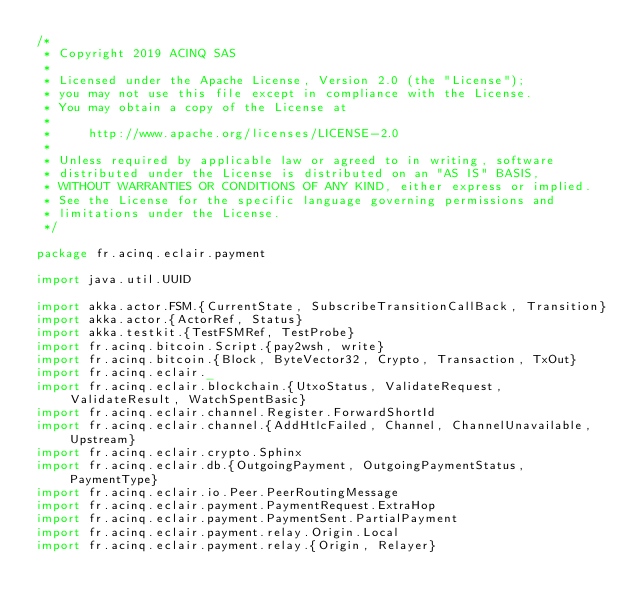Convert code to text. <code><loc_0><loc_0><loc_500><loc_500><_Scala_>/*
 * Copyright 2019 ACINQ SAS
 *
 * Licensed under the Apache License, Version 2.0 (the "License");
 * you may not use this file except in compliance with the License.
 * You may obtain a copy of the License at
 *
 *     http://www.apache.org/licenses/LICENSE-2.0
 *
 * Unless required by applicable law or agreed to in writing, software
 * distributed under the License is distributed on an "AS IS" BASIS,
 * WITHOUT WARRANTIES OR CONDITIONS OF ANY KIND, either express or implied.
 * See the License for the specific language governing permissions and
 * limitations under the License.
 */

package fr.acinq.eclair.payment

import java.util.UUID

import akka.actor.FSM.{CurrentState, SubscribeTransitionCallBack, Transition}
import akka.actor.{ActorRef, Status}
import akka.testkit.{TestFSMRef, TestProbe}
import fr.acinq.bitcoin.Script.{pay2wsh, write}
import fr.acinq.bitcoin.{Block, ByteVector32, Crypto, Transaction, TxOut}
import fr.acinq.eclair._
import fr.acinq.eclair.blockchain.{UtxoStatus, ValidateRequest, ValidateResult, WatchSpentBasic}
import fr.acinq.eclair.channel.Register.ForwardShortId
import fr.acinq.eclair.channel.{AddHtlcFailed, Channel, ChannelUnavailable, Upstream}
import fr.acinq.eclair.crypto.Sphinx
import fr.acinq.eclair.db.{OutgoingPayment, OutgoingPaymentStatus, PaymentType}
import fr.acinq.eclair.io.Peer.PeerRoutingMessage
import fr.acinq.eclair.payment.PaymentRequest.ExtraHop
import fr.acinq.eclair.payment.PaymentSent.PartialPayment
import fr.acinq.eclair.payment.relay.Origin.Local
import fr.acinq.eclair.payment.relay.{Origin, Relayer}</code> 